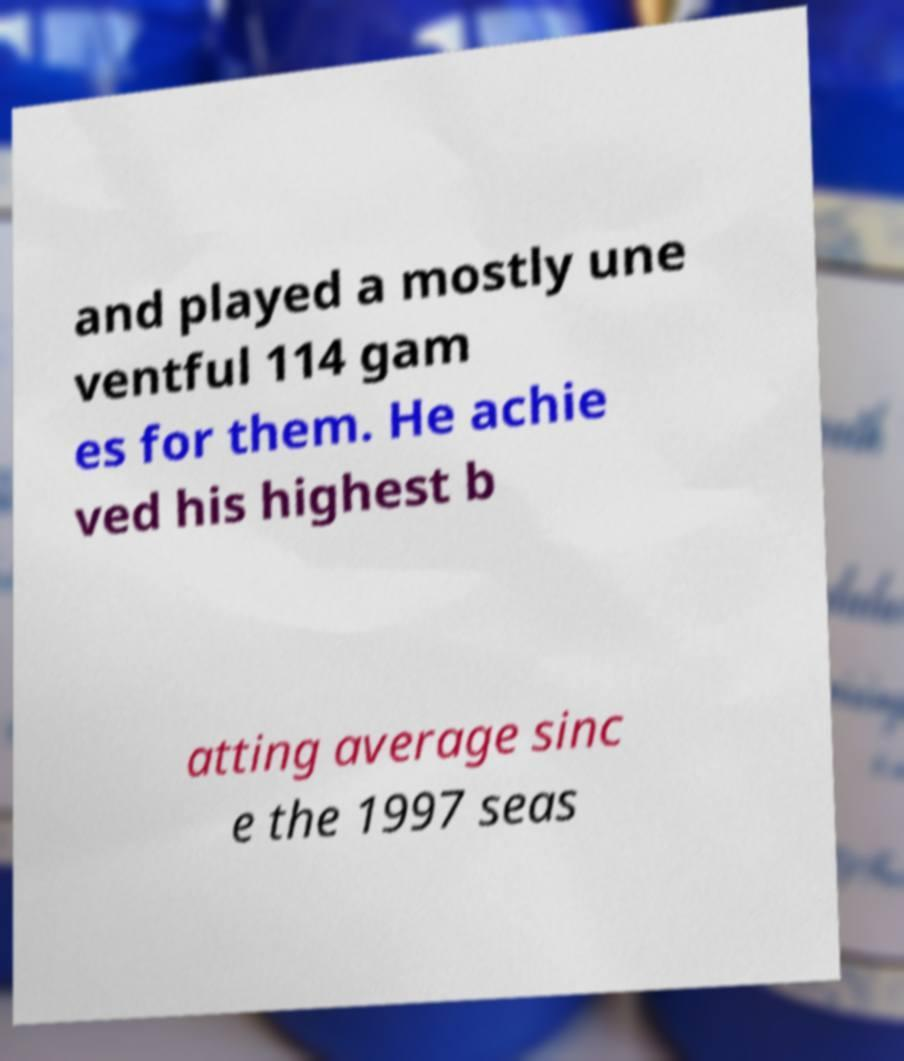Please read and relay the text visible in this image. What does it say? and played a mostly une ventful 114 gam es for them. He achie ved his highest b atting average sinc e the 1997 seas 